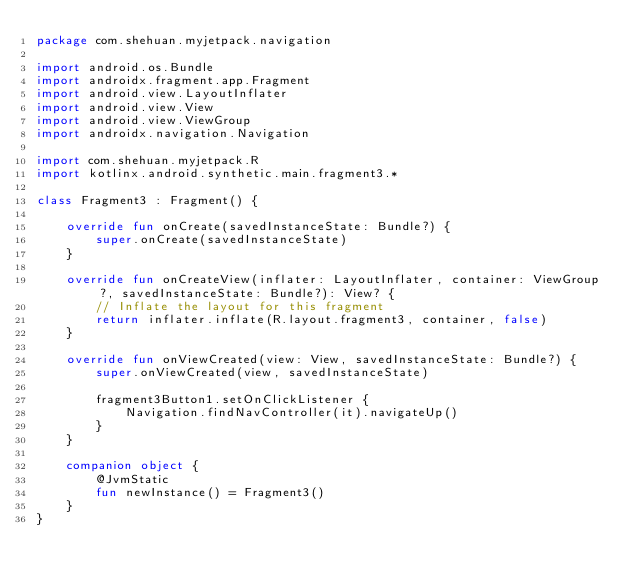Convert code to text. <code><loc_0><loc_0><loc_500><loc_500><_Kotlin_>package com.shehuan.myjetpack.navigation

import android.os.Bundle
import androidx.fragment.app.Fragment
import android.view.LayoutInflater
import android.view.View
import android.view.ViewGroup
import androidx.navigation.Navigation

import com.shehuan.myjetpack.R
import kotlinx.android.synthetic.main.fragment3.*

class Fragment3 : Fragment() {

    override fun onCreate(savedInstanceState: Bundle?) {
        super.onCreate(savedInstanceState)
    }

    override fun onCreateView(inflater: LayoutInflater, container: ViewGroup?, savedInstanceState: Bundle?): View? {
        // Inflate the layout for this fragment
        return inflater.inflate(R.layout.fragment3, container, false)
    }

    override fun onViewCreated(view: View, savedInstanceState: Bundle?) {
        super.onViewCreated(view, savedInstanceState)

        fragment3Button1.setOnClickListener {
            Navigation.findNavController(it).navigateUp()
        }
    }

    companion object {
        @JvmStatic
        fun newInstance() = Fragment3()
    }
}
</code> 